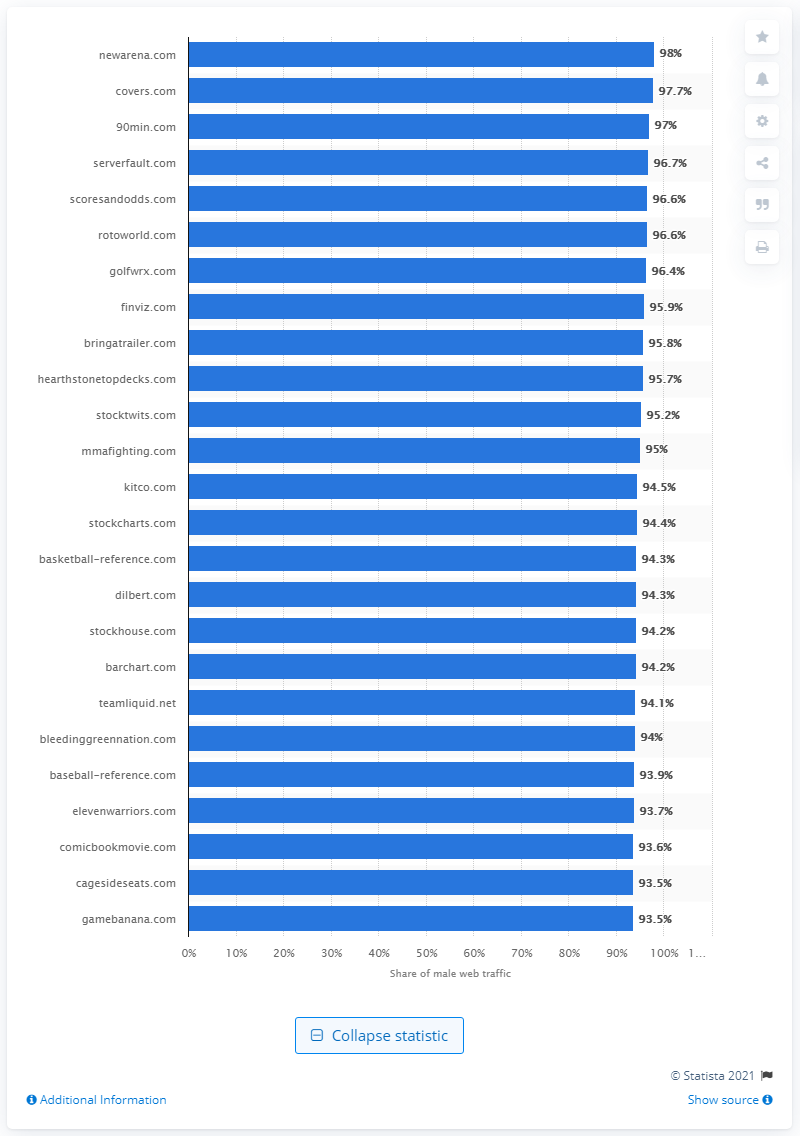Point out several critical features in this image. According to the data provided, the male audience traffic share on rotoworld.com was 97%. According to a website report, newarena.com received the highest share of male visitor web traffic. 